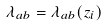<formula> <loc_0><loc_0><loc_500><loc_500>\lambda _ { a b } = \lambda _ { a b } ( z _ { i } )</formula> 